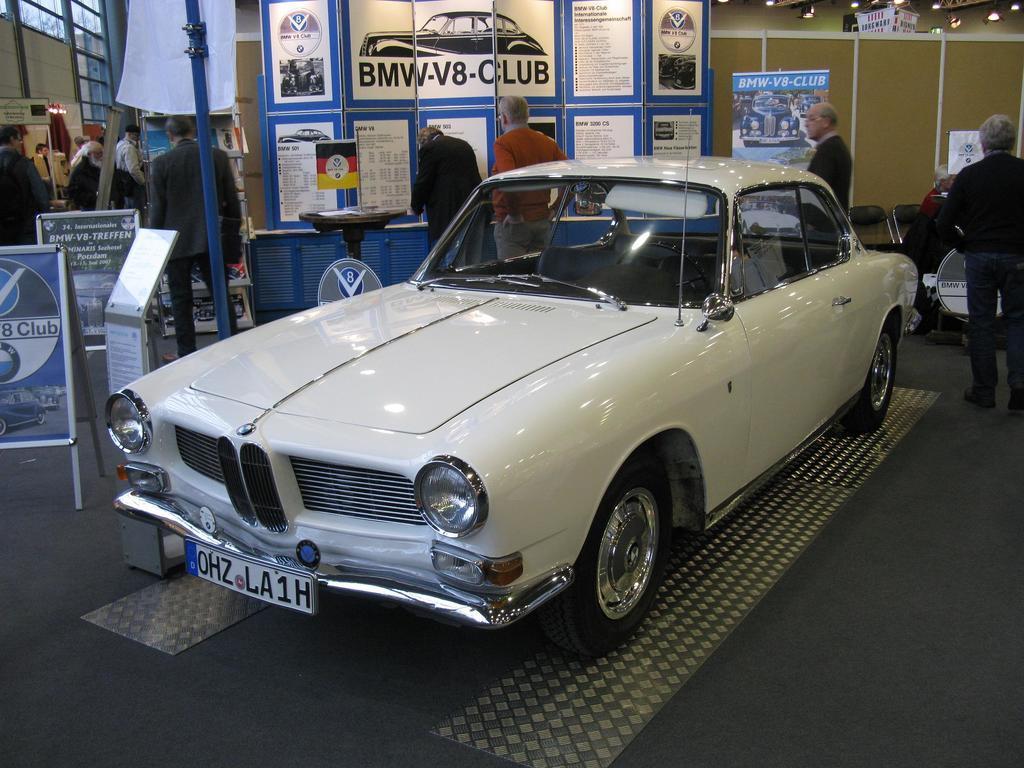Please provide a concise description of this image. In this image there is a white car. In the background there are many people , boards, banners are there. 